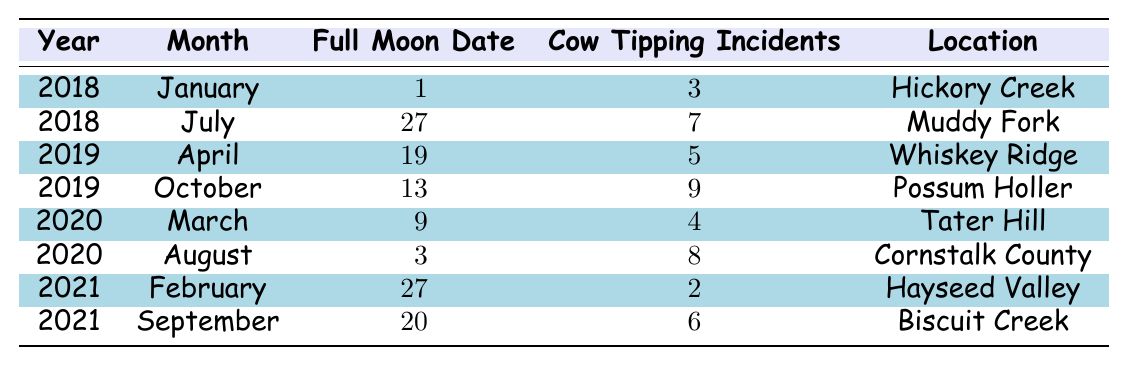What is the total number of cow tipping incidents reported in 2018? In 2018, there are two entries: January with 3 incidents and July with 7 incidents. Summing these gives 3 + 7 = 10.
Answer: 10 Which month in 2020 had the highest number of cow tipping incidents? In 2020, we have March with 4 incidents and August with 8 incidents. August has more incidents than March, so it has the highest.
Answer: August How many cow tipping incidents were reported in January 2019? There is no entry for January 2019 in the table.
Answer: 0 Did the number of cow tipping incidents increase or decrease from July 2018 to October 2019? In July 2018, there were 7 incidents and October 2019 had 9 incidents. Since 9 is greater than 7, the number increased.
Answer: Increased What was the average number of cow tipping incidents across all entries? To find the average, list all reported incidents: 3, 7, 5, 9, 4, 8, 2, 6. Summing these gives 44, and since there are 8 entries, the average is 44/8 = 5.5.
Answer: 5.5 Which location had the most cow tipping incidents in a single entry? The highest entry is from October 2019 at Possum Holler with 9 incidents. No other entry surpasses this count.
Answer: Possum Holler Was there ever a month with zero cow tipping incidents in the years listed? There are no entries that indicate zero incidents. Each month listed has at least 2 incidents recorded.
Answer: No How many total incidents were reported during full moons that fell on the 3rd day of the month? The only entry that falls on the 3rd day what August 2020 with 8 incidents; thus the total is only 8 incidents.
Answer: 8 What is the difference in the number of incidents between the month with the least incidents and the month with the most incidents? The least incidents recorded is 2 in February 2021, and the most is 9 in October 2019. The difference is 9 - 2 = 7.
Answer: 7 Which year saw the least total cow tipping incidents across all months? Adding incidents for each year: 2018 = 10, 2019 = 14, 2020 = 12, 2021 = 8. The least total incidents is in 2021 with 8 incidents.
Answer: 2021 